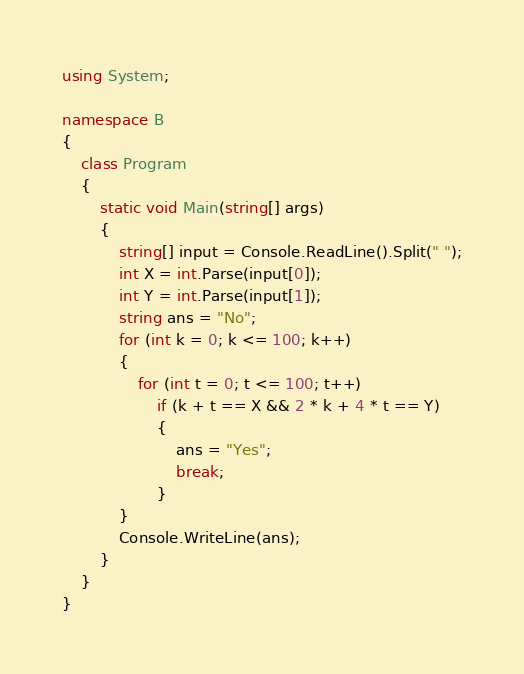<code> <loc_0><loc_0><loc_500><loc_500><_C#_>using System;

namespace B
{
    class Program
    {
        static void Main(string[] args)
        {
            string[] input = Console.ReadLine().Split(" ");
            int X = int.Parse(input[0]);
            int Y = int.Parse(input[1]);
            string ans = "No";
            for (int k = 0; k <= 100; k++)
            {
                for (int t = 0; t <= 100; t++)
                    if (k + t == X && 2 * k + 4 * t == Y)
                    {
                        ans = "Yes";
                        break;
                    }
            }
            Console.WriteLine(ans);
        }
    }
}
</code> 